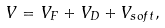<formula> <loc_0><loc_0><loc_500><loc_500>V = V _ { F } + V _ { D } + V _ { s o f t } ,</formula> 